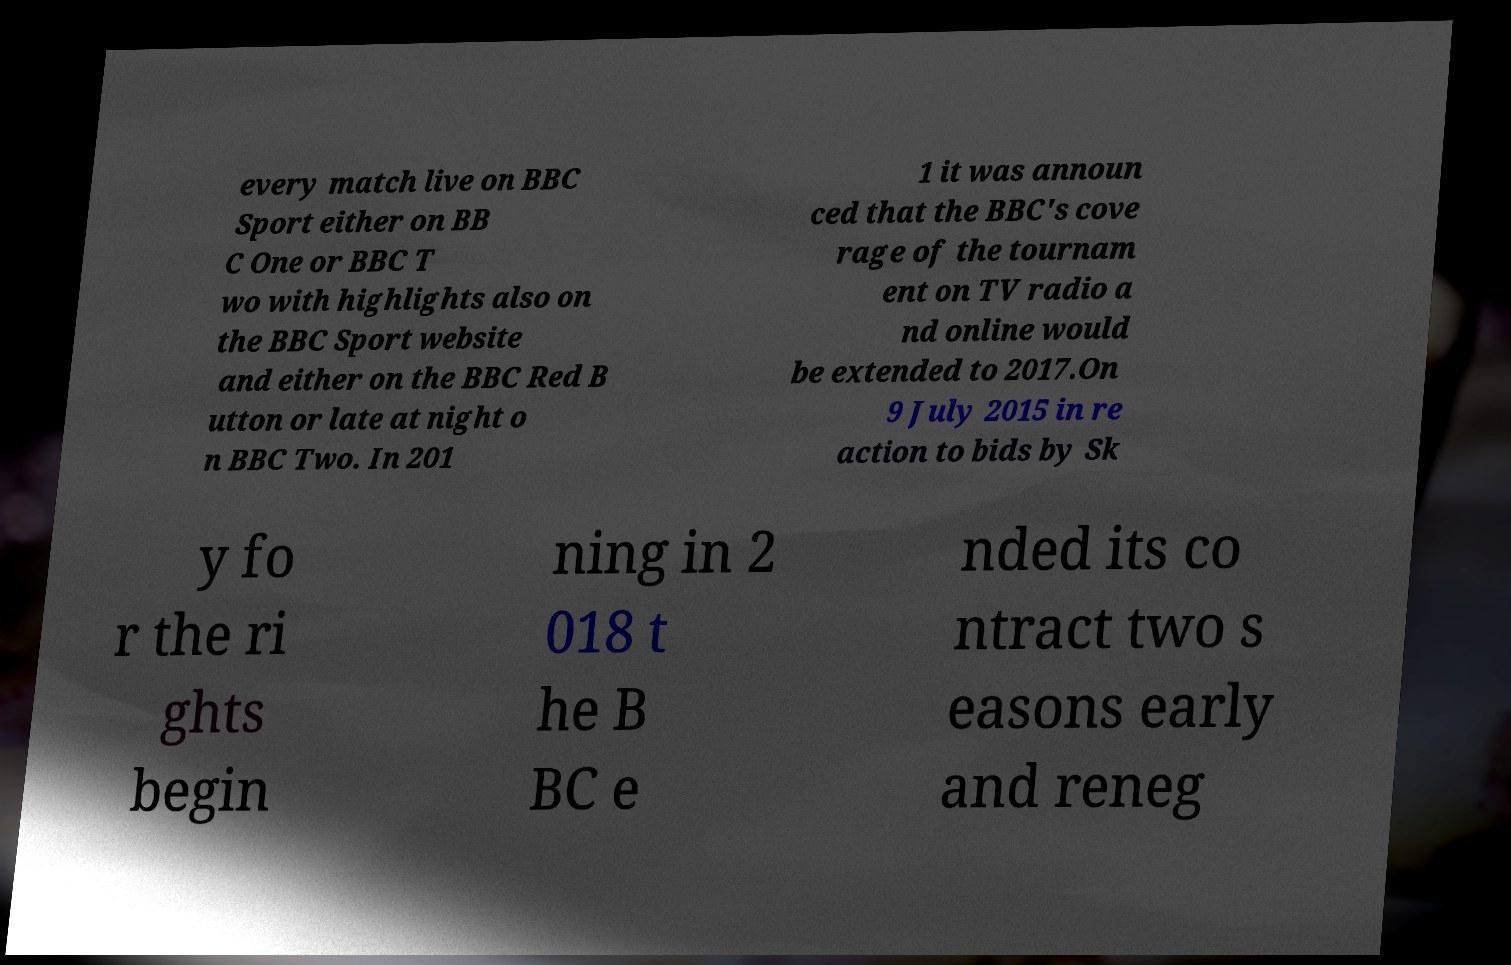I need the written content from this picture converted into text. Can you do that? every match live on BBC Sport either on BB C One or BBC T wo with highlights also on the BBC Sport website and either on the BBC Red B utton or late at night o n BBC Two. In 201 1 it was announ ced that the BBC's cove rage of the tournam ent on TV radio a nd online would be extended to 2017.On 9 July 2015 in re action to bids by Sk y fo r the ri ghts begin ning in 2 018 t he B BC e nded its co ntract two s easons early and reneg 